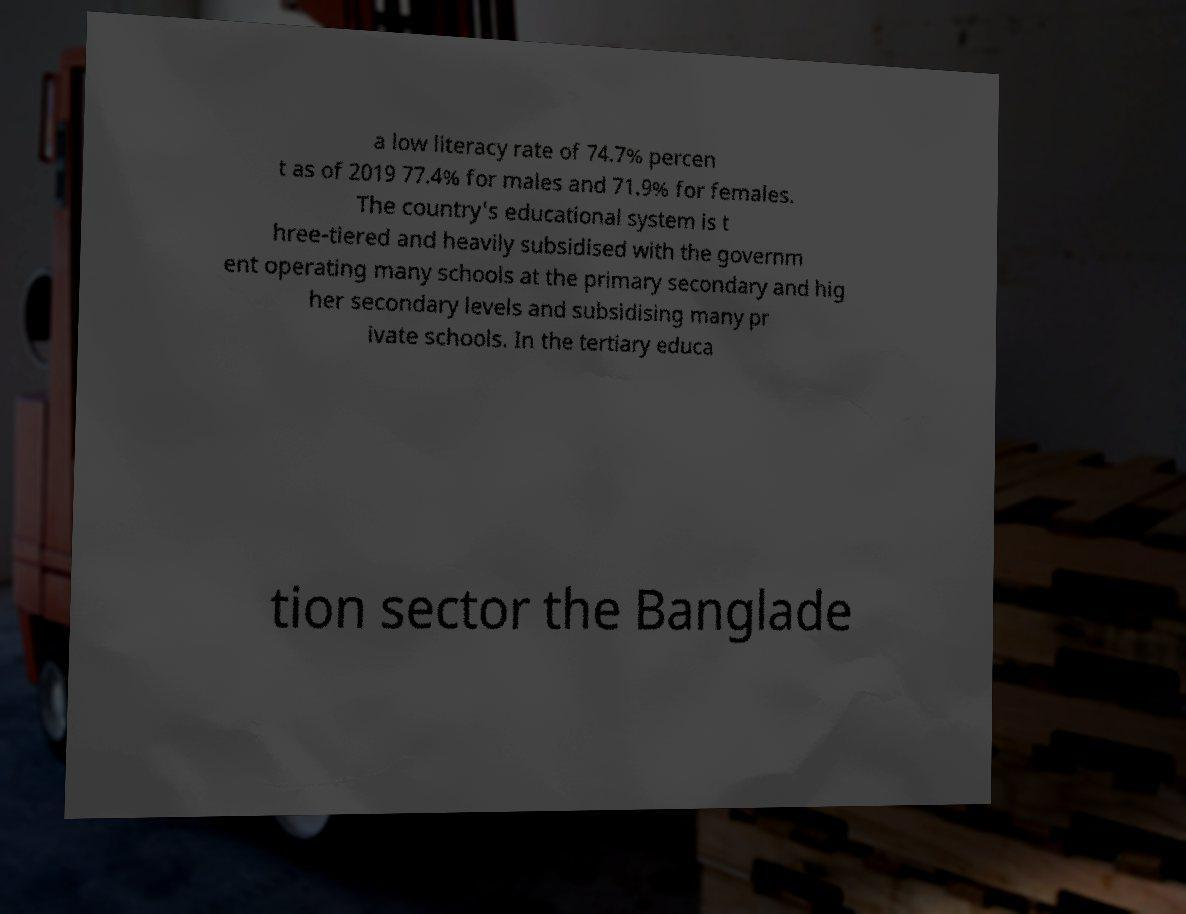Please identify and transcribe the text found in this image. a low literacy rate of 74.7% percen t as of 2019 77.4% for males and 71.9% for females. The country's educational system is t hree-tiered and heavily subsidised with the governm ent operating many schools at the primary secondary and hig her secondary levels and subsidising many pr ivate schools. In the tertiary educa tion sector the Banglade 